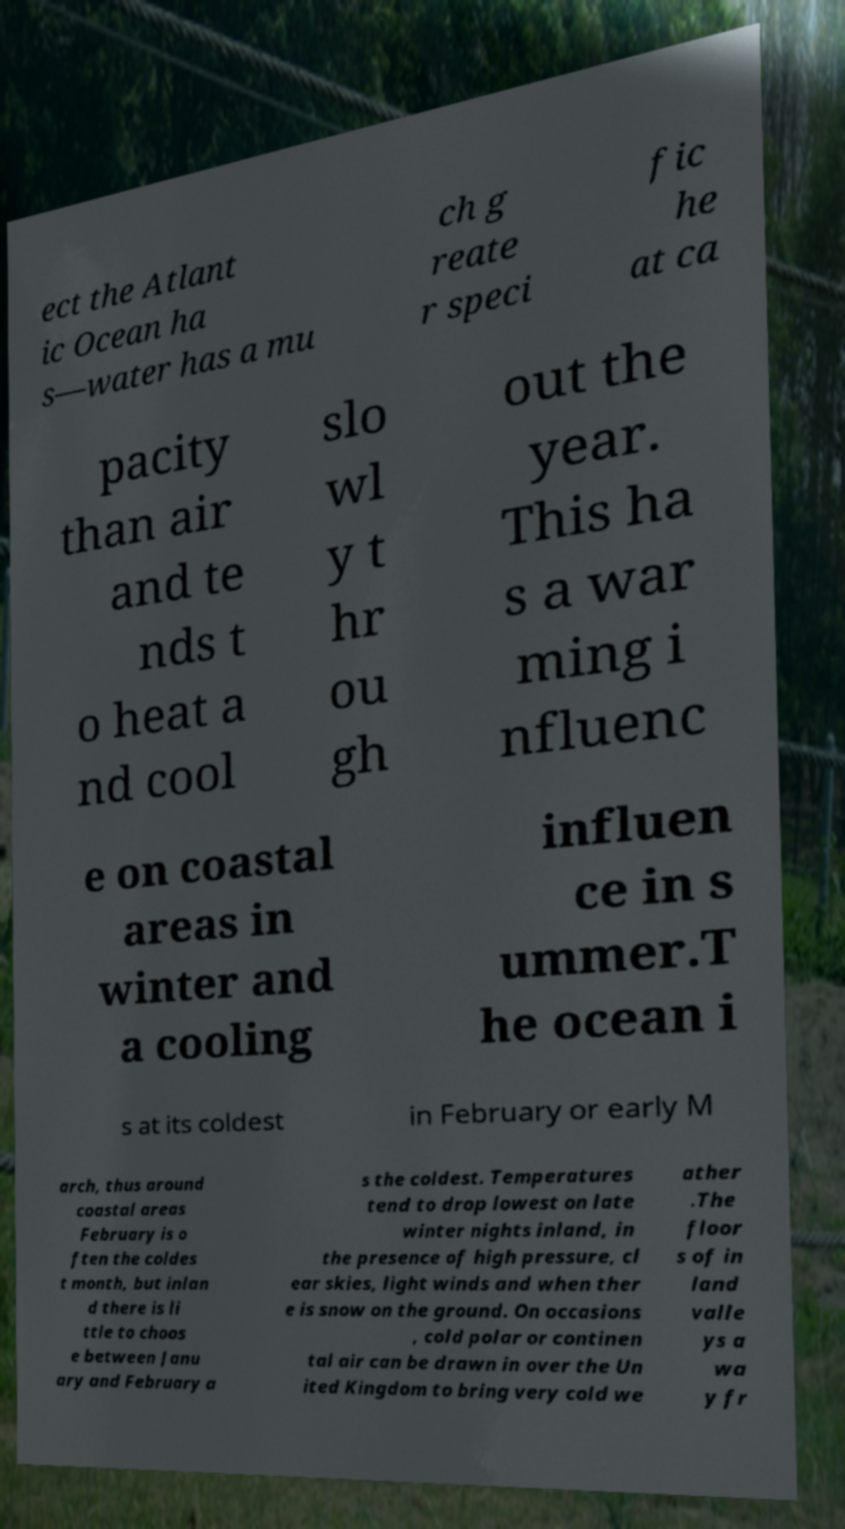For documentation purposes, I need the text within this image transcribed. Could you provide that? ect the Atlant ic Ocean ha s—water has a mu ch g reate r speci fic he at ca pacity than air and te nds t o heat a nd cool slo wl y t hr ou gh out the year. This ha s a war ming i nfluenc e on coastal areas in winter and a cooling influen ce in s ummer.T he ocean i s at its coldest in February or early M arch, thus around coastal areas February is o ften the coldes t month, but inlan d there is li ttle to choos e between Janu ary and February a s the coldest. Temperatures tend to drop lowest on late winter nights inland, in the presence of high pressure, cl ear skies, light winds and when ther e is snow on the ground. On occasions , cold polar or continen tal air can be drawn in over the Un ited Kingdom to bring very cold we ather .The floor s of in land valle ys a wa y fr 